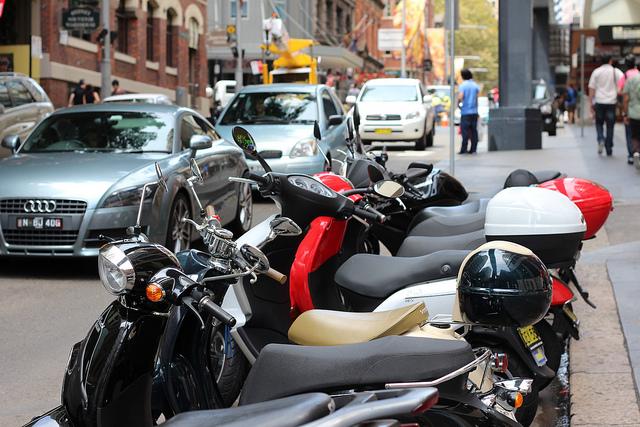Are the vehicles in the city or the country?
Be succinct. City. What model car is first in line?
Write a very short answer. Audi. What kinds of vehicles are shown?
Answer briefly. Motorcycles. 